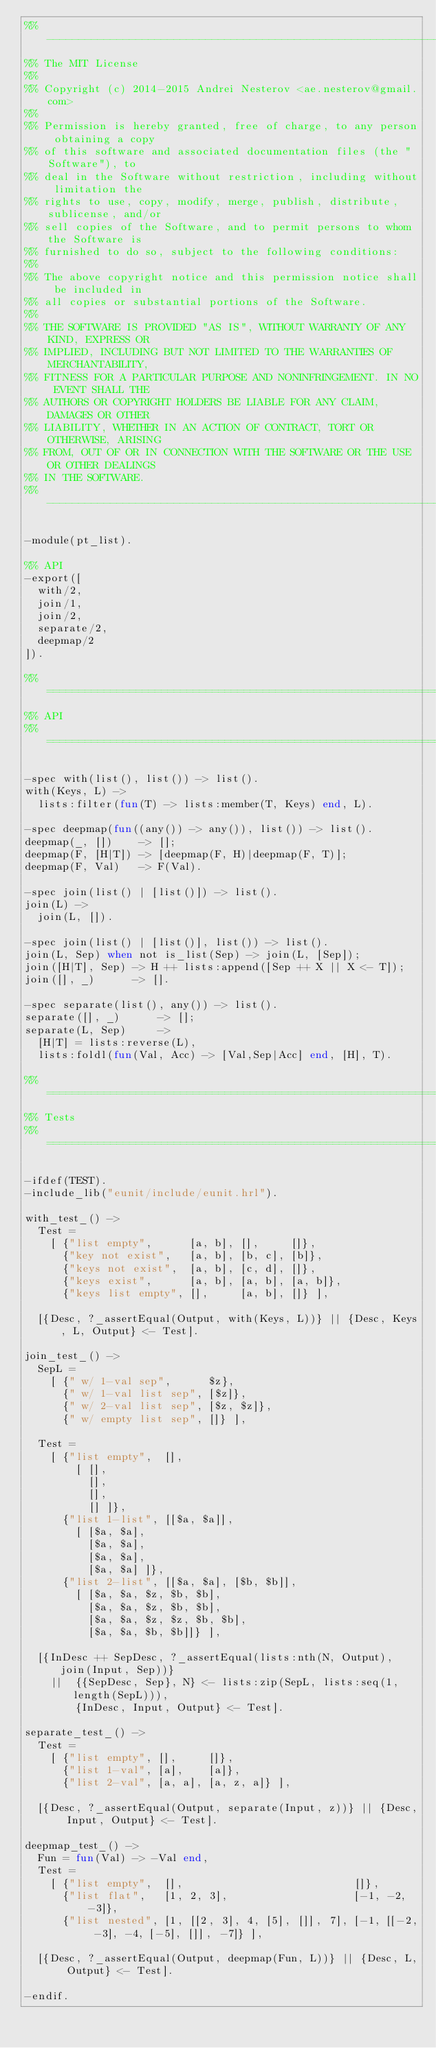Convert code to text. <code><loc_0><loc_0><loc_500><loc_500><_Erlang_>%% ----------------------------------------------------------------------------
%% The MIT License
%%
%% Copyright (c) 2014-2015 Andrei Nesterov <ae.nesterov@gmail.com>
%%
%% Permission is hereby granted, free of charge, to any person obtaining a copy
%% of this software and associated documentation files (the "Software"), to
%% deal in the Software without restriction, including without limitation the
%% rights to use, copy, modify, merge, publish, distribute, sublicense, and/or
%% sell copies of the Software, and to permit persons to whom the Software is
%% furnished to do so, subject to the following conditions:
%%
%% The above copyright notice and this permission notice shall be included in
%% all copies or substantial portions of the Software.
%%
%% THE SOFTWARE IS PROVIDED "AS IS", WITHOUT WARRANTY OF ANY KIND, EXPRESS OR
%% IMPLIED, INCLUDING BUT NOT LIMITED TO THE WARRANTIES OF MERCHANTABILITY,
%% FITNESS FOR A PARTICULAR PURPOSE AND NONINFRINGEMENT. IN NO EVENT SHALL THE
%% AUTHORS OR COPYRIGHT HOLDERS BE LIABLE FOR ANY CLAIM, DAMAGES OR OTHER
%% LIABILITY, WHETHER IN AN ACTION OF CONTRACT, TORT OR OTHERWISE, ARISING
%% FROM, OUT OF OR IN CONNECTION WITH THE SOFTWARE OR THE USE OR OTHER DEALINGS
%% IN THE SOFTWARE.
%% ----------------------------------------------------------------------------

-module(pt_list).

%% API
-export([
	with/2,
	join/1,
	join/2,
	separate/2,
	deepmap/2
]).

%% ============================================================================
%% API
%% ============================================================================

-spec with(list(), list()) -> list().
with(Keys, L) ->
	lists:filter(fun(T) -> lists:member(T, Keys) end, L).

-spec deepmap(fun((any()) -> any()), list()) -> list().
deepmap(_, [])    -> [];
deepmap(F, [H|T]) -> [deepmap(F, H)|deepmap(F, T)];
deepmap(F, Val)   -> F(Val).

-spec join(list() | [list()]) -> list().
join(L) ->
	join(L, []).

-spec join(list() | [list()], list()) -> list().
join(L, Sep) when not is_list(Sep) -> join(L, [Sep]);
join([H|T], Sep) -> H ++ lists:append([Sep ++ X || X <- T]);
join([], _)      -> [].

-spec separate(list(), any()) -> list().
separate([], _)      -> [];
separate(L, Sep)     ->
	[H|T] = lists:reverse(L),
	lists:foldl(fun(Val, Acc) -> [Val,Sep|Acc] end, [H], T).

%% ============================================================================
%% Tests 
%% ============================================================================

-ifdef(TEST).
-include_lib("eunit/include/eunit.hrl").

with_test_() ->
	Test =
		[	{"list empty",      [a, b], [],     []},
			{"key not exist",   [a, b], [b, c], [b]},
			{"keys not exist",  [a, b], [c, d], []},
			{"keys exist",      [a, b], [a, b], [a, b]},
			{"keys list empty", [],     [a, b], []} ],

	[{Desc, ?_assertEqual(Output, with(Keys, L))} || {Desc, Keys, L, Output} <- Test].

join_test_() ->
	SepL =
		[	{" w/ 1-val sep",      $z},
			{" w/ 1-val list sep", [$z]},
			{" w/ 2-val list sep", [$z, $z]},
			{" w/ empty list sep", []} ],

	Test =
		[	{"list empty",  [],
				[	[],
					[],
					[],
					[] ]},
			{"list 1-list", [[$a, $a]],
				[	[$a, $a],
					[$a, $a],
					[$a, $a],
					[$a, $a] ]},
			{"list 2-list", [[$a, $a], [$b, $b]],
				[	[$a, $a, $z, $b, $b],
					[$a, $a, $z, $b, $b],
					[$a, $a, $z, $z, $b, $b],
					[$a, $a, $b, $b]]} ],

	[{InDesc ++ SepDesc, ?_assertEqual(lists:nth(N, Output), join(Input, Sep))}
		||	{{SepDesc, Sep}, N} <- lists:zip(SepL, lists:seq(1, length(SepL))),
				{InDesc, Input, Output} <- Test].

separate_test_() ->
	Test =
		[	{"list empty", [],     []},
			{"list 1-val", [a],    [a]},
			{"list 2-val", [a, a], [a, z, a]} ],

	[{Desc, ?_assertEqual(Output, separate(Input, z))} || {Desc, Input, Output} <- Test].

deepmap_test_() ->
	Fun = fun(Val) -> -Val end,
	Test =
		[	{"list empty",  [],                           []},
			{"list flat",   [1, 2, 3],                    [-1, -2, -3]},
			{"list nested", [1, [[2, 3], 4, [5], []], 7], [-1, [[-2, -3], -4, [-5], []], -7]} ],
	
	[{Desc, ?_assertEqual(Output, deepmap(Fun, L))} || {Desc, L, Output} <- Test].

-endif.

</code> 